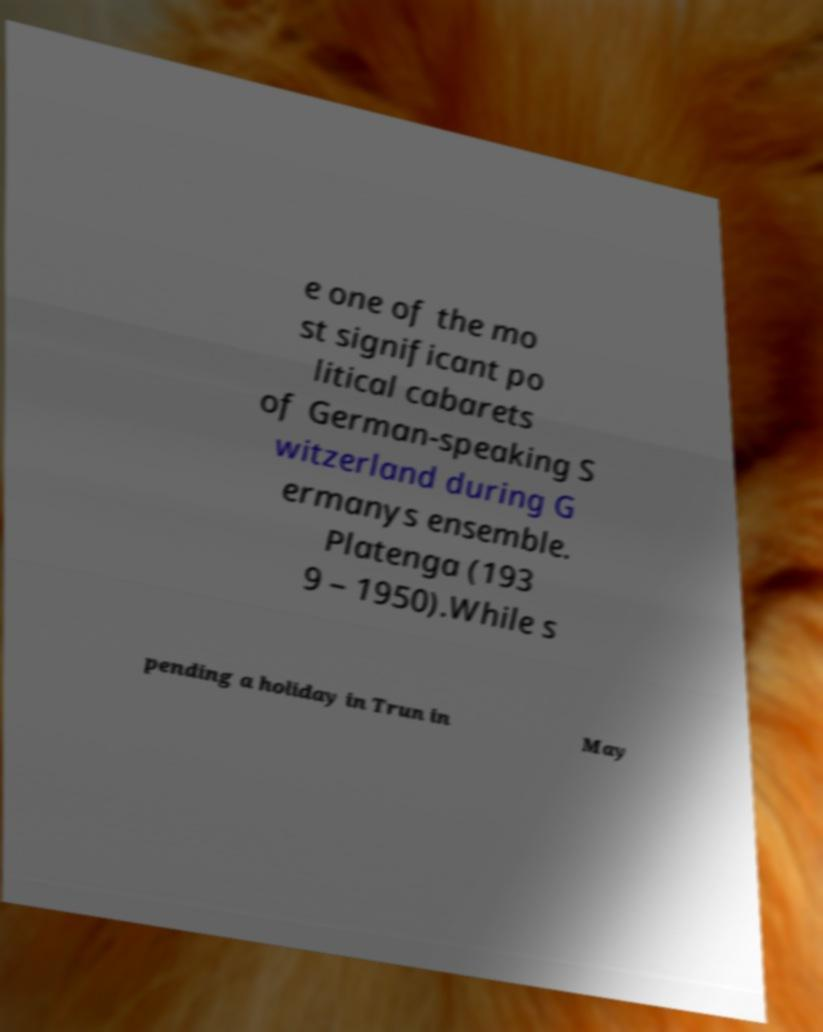Please identify and transcribe the text found in this image. e one of the mo st significant po litical cabarets of German-speaking S witzerland during G ermanys ensemble. Platenga (193 9 – 1950).While s pending a holiday in Trun in May 